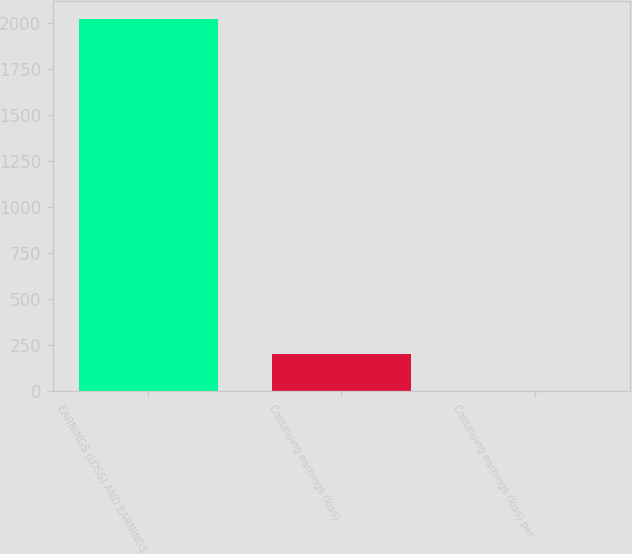<chart> <loc_0><loc_0><loc_500><loc_500><bar_chart><fcel>EARNINGS (LOSS) AND EARNINGS<fcel>Continuing earnings (loss)<fcel>Continuing earnings (loss) per<nl><fcel>2017<fcel>202.59<fcel>0.99<nl></chart> 